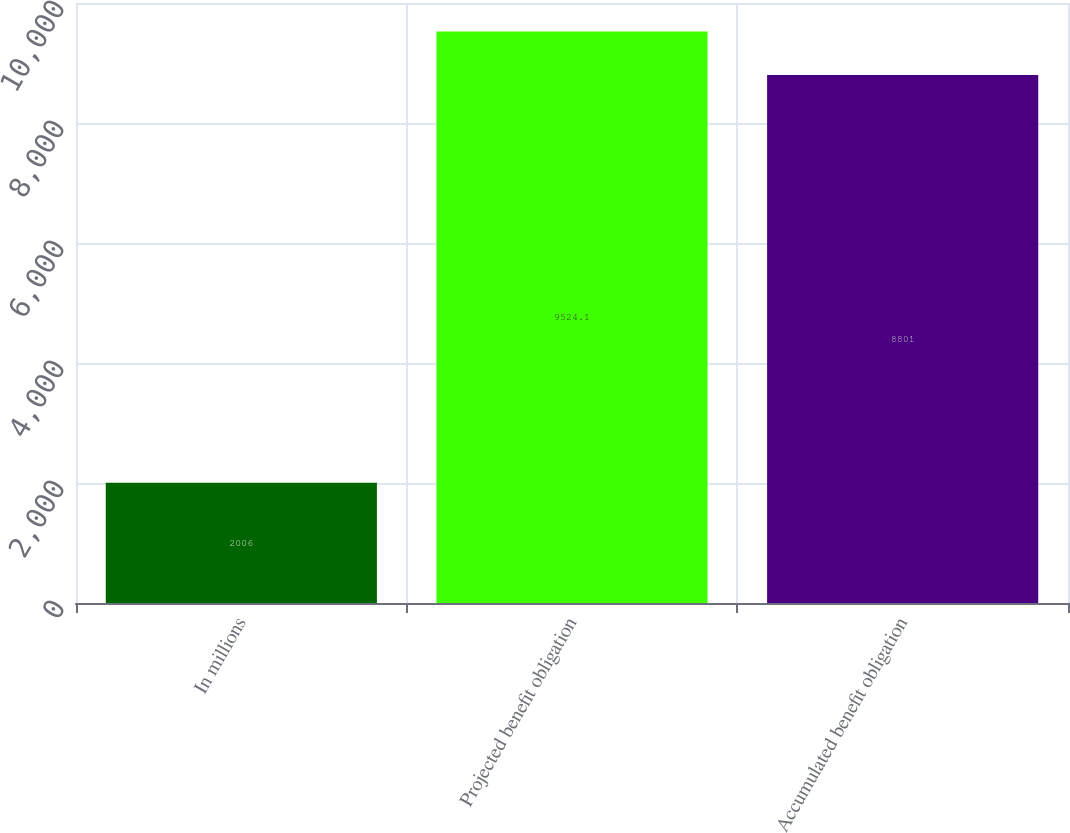<chart> <loc_0><loc_0><loc_500><loc_500><bar_chart><fcel>In millions<fcel>Projected benefit obligation<fcel>Accumulated benefit obligation<nl><fcel>2006<fcel>9524.1<fcel>8801<nl></chart> 